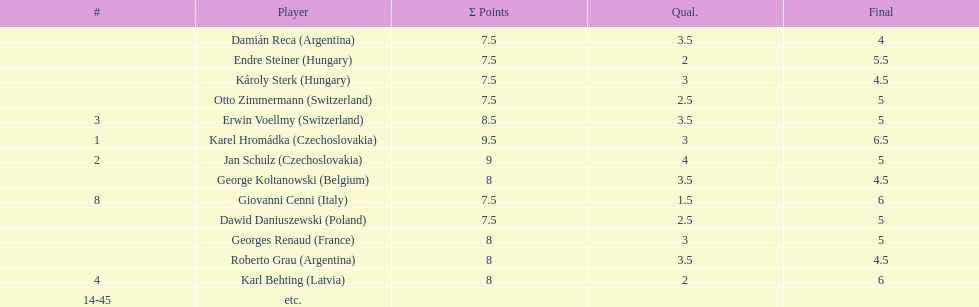How many players had a 8 points? 4. 